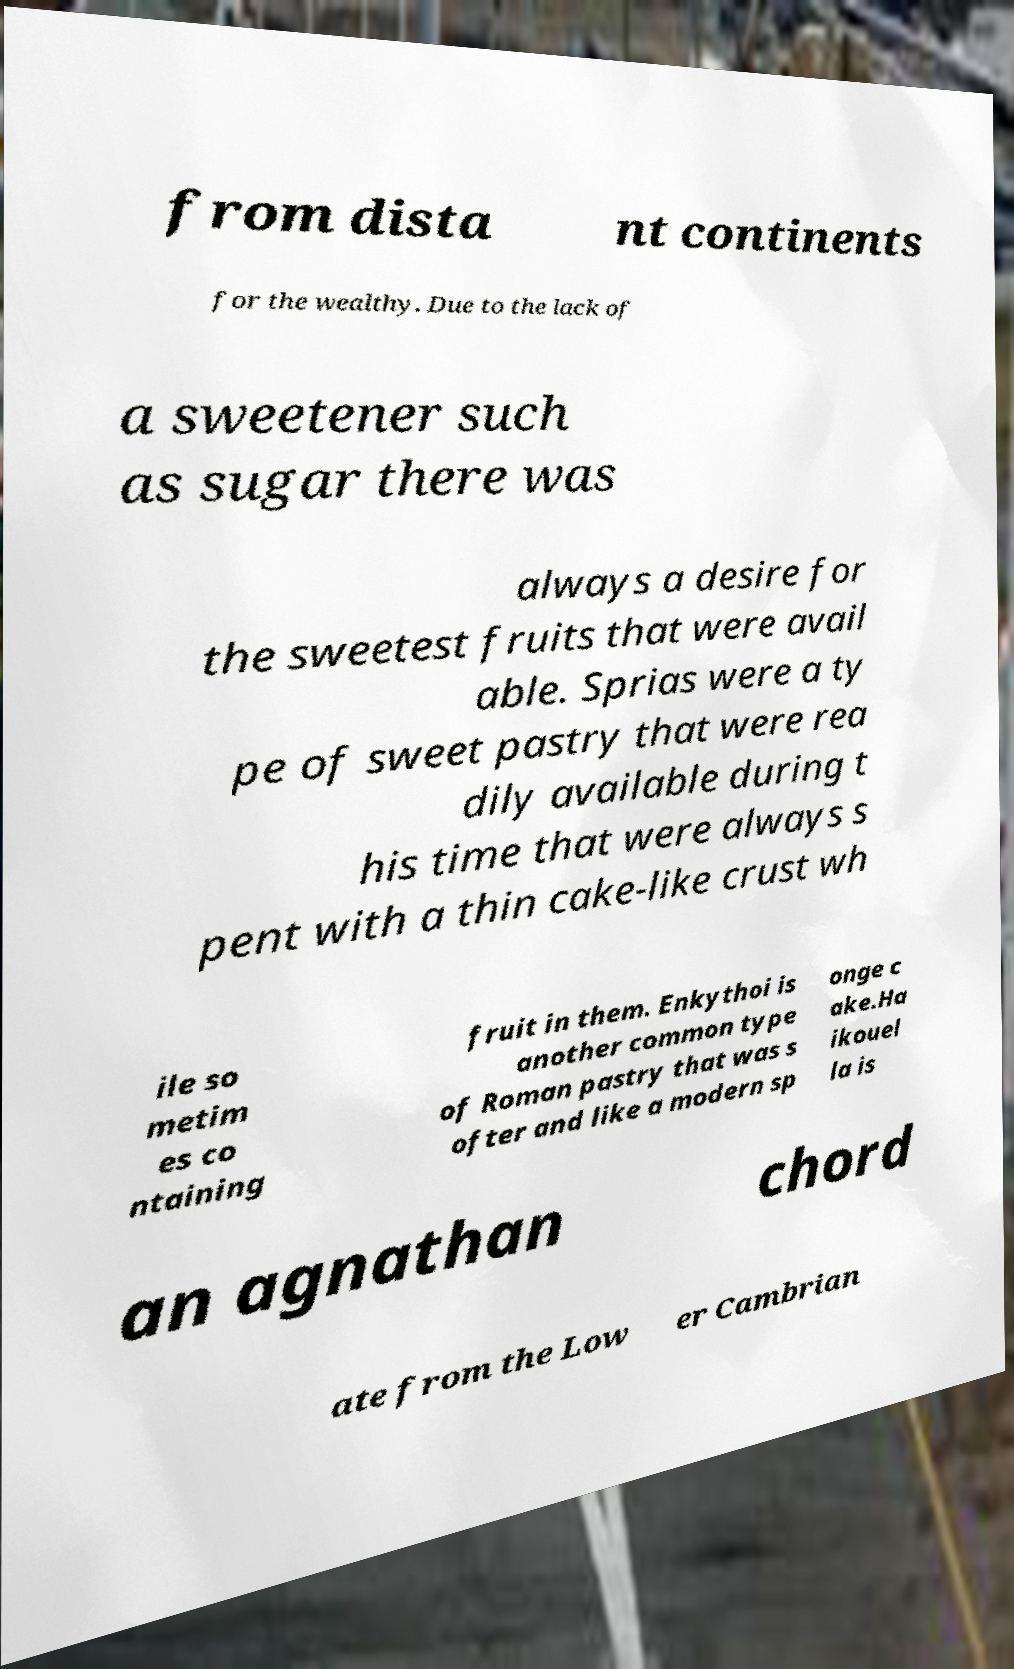Can you accurately transcribe the text from the provided image for me? from dista nt continents for the wealthy. Due to the lack of a sweetener such as sugar there was always a desire for the sweetest fruits that were avail able. Sprias were a ty pe of sweet pastry that were rea dily available during t his time that were always s pent with a thin cake-like crust wh ile so metim es co ntaining fruit in them. Enkythoi is another common type of Roman pastry that was s ofter and like a modern sp onge c ake.Ha ikouel la is an agnathan chord ate from the Low er Cambrian 